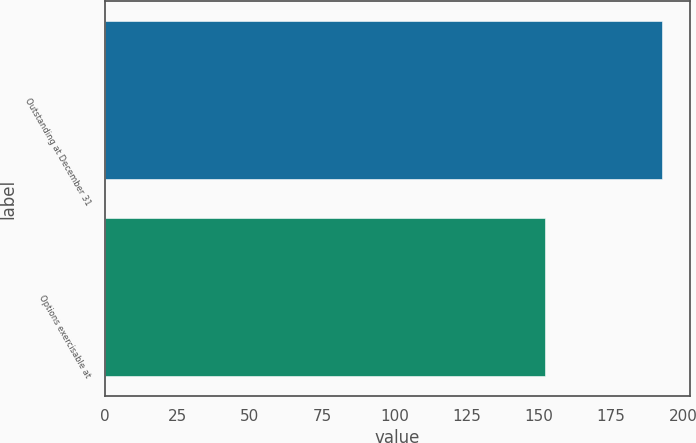Convert chart to OTSL. <chart><loc_0><loc_0><loc_500><loc_500><bar_chart><fcel>Outstanding at December 31<fcel>Options exercisable at<nl><fcel>192.63<fcel>152.23<nl></chart> 